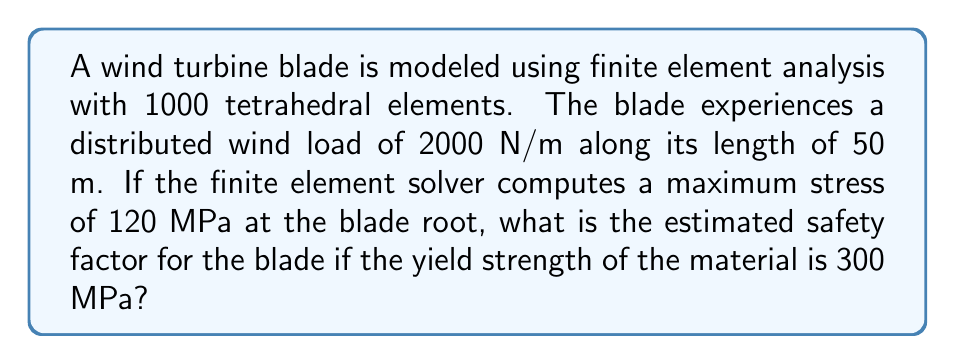Could you help me with this problem? To solve this problem, we'll follow these steps:

1. Understand the given information:
   - Number of elements: 1000 tetrahedral elements
   - Distributed wind load: 2000 N/m
   - Blade length: 50 m
   - Maximum computed stress: 120 MPa
   - Material yield strength: 300 MPa

2. Calculate the total wind load on the blade:
   $$F_{total} = 2000 \text{ N/m} \times 50 \text{ m} = 100,000 \text{ N}$$

3. The finite element analysis has already computed the maximum stress at the blade root:
   $$\sigma_{max} = 120 \text{ MPa}$$

4. Calculate the safety factor:
   The safety factor is defined as the ratio of the material's yield strength to the maximum stress experienced by the component.

   $$\text{Safety Factor} = \frac{\text{Yield Strength}}{\text{Maximum Stress}}$$

   $$\text{Safety Factor} = \frac{300 \text{ MPa}}{120 \text{ MPa}} = 2.5$$

5. Interpret the result:
   A safety factor of 2.5 indicates that the blade can withstand stresses up to 2.5 times the current maximum stress before reaching its yield point.
Answer: 2.5 